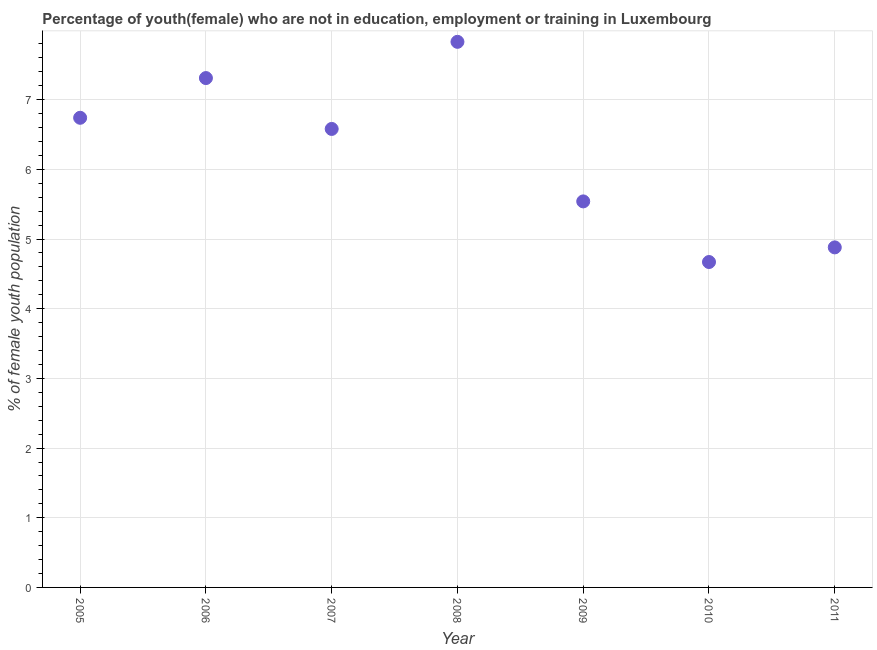What is the unemployed female youth population in 2011?
Provide a succinct answer. 4.88. Across all years, what is the maximum unemployed female youth population?
Your response must be concise. 7.83. Across all years, what is the minimum unemployed female youth population?
Offer a terse response. 4.67. In which year was the unemployed female youth population minimum?
Ensure brevity in your answer.  2010. What is the sum of the unemployed female youth population?
Make the answer very short. 43.55. What is the difference between the unemployed female youth population in 2006 and 2008?
Offer a terse response. -0.52. What is the average unemployed female youth population per year?
Your response must be concise. 6.22. What is the median unemployed female youth population?
Ensure brevity in your answer.  6.58. Do a majority of the years between 2005 and 2008 (inclusive) have unemployed female youth population greater than 7.2 %?
Your answer should be compact. No. What is the ratio of the unemployed female youth population in 2008 to that in 2010?
Ensure brevity in your answer.  1.68. What is the difference between the highest and the second highest unemployed female youth population?
Your answer should be compact. 0.52. What is the difference between the highest and the lowest unemployed female youth population?
Provide a short and direct response. 3.16. How many dotlines are there?
Ensure brevity in your answer.  1. How many years are there in the graph?
Offer a terse response. 7. What is the difference between two consecutive major ticks on the Y-axis?
Your answer should be very brief. 1. Are the values on the major ticks of Y-axis written in scientific E-notation?
Your answer should be very brief. No. What is the title of the graph?
Provide a succinct answer. Percentage of youth(female) who are not in education, employment or training in Luxembourg. What is the label or title of the X-axis?
Keep it short and to the point. Year. What is the label or title of the Y-axis?
Provide a short and direct response. % of female youth population. What is the % of female youth population in 2005?
Provide a short and direct response. 6.74. What is the % of female youth population in 2006?
Provide a succinct answer. 7.31. What is the % of female youth population in 2007?
Keep it short and to the point. 6.58. What is the % of female youth population in 2008?
Give a very brief answer. 7.83. What is the % of female youth population in 2009?
Provide a succinct answer. 5.54. What is the % of female youth population in 2010?
Make the answer very short. 4.67. What is the % of female youth population in 2011?
Provide a succinct answer. 4.88. What is the difference between the % of female youth population in 2005 and 2006?
Offer a terse response. -0.57. What is the difference between the % of female youth population in 2005 and 2007?
Provide a short and direct response. 0.16. What is the difference between the % of female youth population in 2005 and 2008?
Ensure brevity in your answer.  -1.09. What is the difference between the % of female youth population in 2005 and 2009?
Your answer should be compact. 1.2. What is the difference between the % of female youth population in 2005 and 2010?
Provide a succinct answer. 2.07. What is the difference between the % of female youth population in 2005 and 2011?
Ensure brevity in your answer.  1.86. What is the difference between the % of female youth population in 2006 and 2007?
Offer a very short reply. 0.73. What is the difference between the % of female youth population in 2006 and 2008?
Make the answer very short. -0.52. What is the difference between the % of female youth population in 2006 and 2009?
Your response must be concise. 1.77. What is the difference between the % of female youth population in 2006 and 2010?
Provide a succinct answer. 2.64. What is the difference between the % of female youth population in 2006 and 2011?
Your response must be concise. 2.43. What is the difference between the % of female youth population in 2007 and 2008?
Give a very brief answer. -1.25. What is the difference between the % of female youth population in 2007 and 2010?
Your response must be concise. 1.91. What is the difference between the % of female youth population in 2007 and 2011?
Your answer should be compact. 1.7. What is the difference between the % of female youth population in 2008 and 2009?
Your answer should be very brief. 2.29. What is the difference between the % of female youth population in 2008 and 2010?
Offer a very short reply. 3.16. What is the difference between the % of female youth population in 2008 and 2011?
Offer a terse response. 2.95. What is the difference between the % of female youth population in 2009 and 2010?
Your answer should be very brief. 0.87. What is the difference between the % of female youth population in 2009 and 2011?
Keep it short and to the point. 0.66. What is the difference between the % of female youth population in 2010 and 2011?
Provide a short and direct response. -0.21. What is the ratio of the % of female youth population in 2005 to that in 2006?
Give a very brief answer. 0.92. What is the ratio of the % of female youth population in 2005 to that in 2008?
Provide a succinct answer. 0.86. What is the ratio of the % of female youth population in 2005 to that in 2009?
Provide a short and direct response. 1.22. What is the ratio of the % of female youth population in 2005 to that in 2010?
Give a very brief answer. 1.44. What is the ratio of the % of female youth population in 2005 to that in 2011?
Give a very brief answer. 1.38. What is the ratio of the % of female youth population in 2006 to that in 2007?
Provide a succinct answer. 1.11. What is the ratio of the % of female youth population in 2006 to that in 2008?
Keep it short and to the point. 0.93. What is the ratio of the % of female youth population in 2006 to that in 2009?
Provide a succinct answer. 1.32. What is the ratio of the % of female youth population in 2006 to that in 2010?
Provide a short and direct response. 1.56. What is the ratio of the % of female youth population in 2006 to that in 2011?
Ensure brevity in your answer.  1.5. What is the ratio of the % of female youth population in 2007 to that in 2008?
Provide a succinct answer. 0.84. What is the ratio of the % of female youth population in 2007 to that in 2009?
Make the answer very short. 1.19. What is the ratio of the % of female youth population in 2007 to that in 2010?
Provide a succinct answer. 1.41. What is the ratio of the % of female youth population in 2007 to that in 2011?
Give a very brief answer. 1.35. What is the ratio of the % of female youth population in 2008 to that in 2009?
Your response must be concise. 1.41. What is the ratio of the % of female youth population in 2008 to that in 2010?
Your response must be concise. 1.68. What is the ratio of the % of female youth population in 2008 to that in 2011?
Offer a terse response. 1.6. What is the ratio of the % of female youth population in 2009 to that in 2010?
Keep it short and to the point. 1.19. What is the ratio of the % of female youth population in 2009 to that in 2011?
Offer a very short reply. 1.14. 